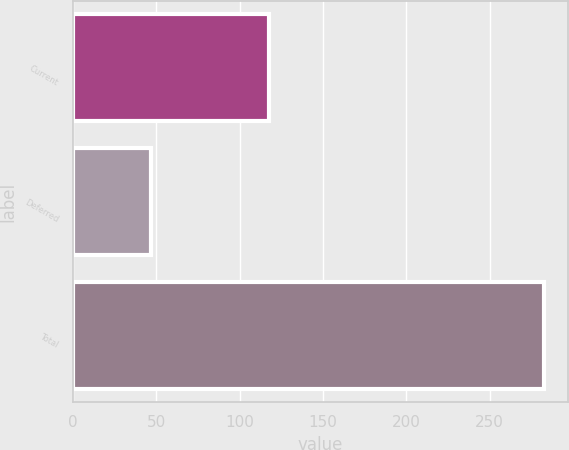Convert chart. <chart><loc_0><loc_0><loc_500><loc_500><bar_chart><fcel>Current<fcel>Deferred<fcel>Total<nl><fcel>117.8<fcel>46.9<fcel>282.8<nl></chart> 